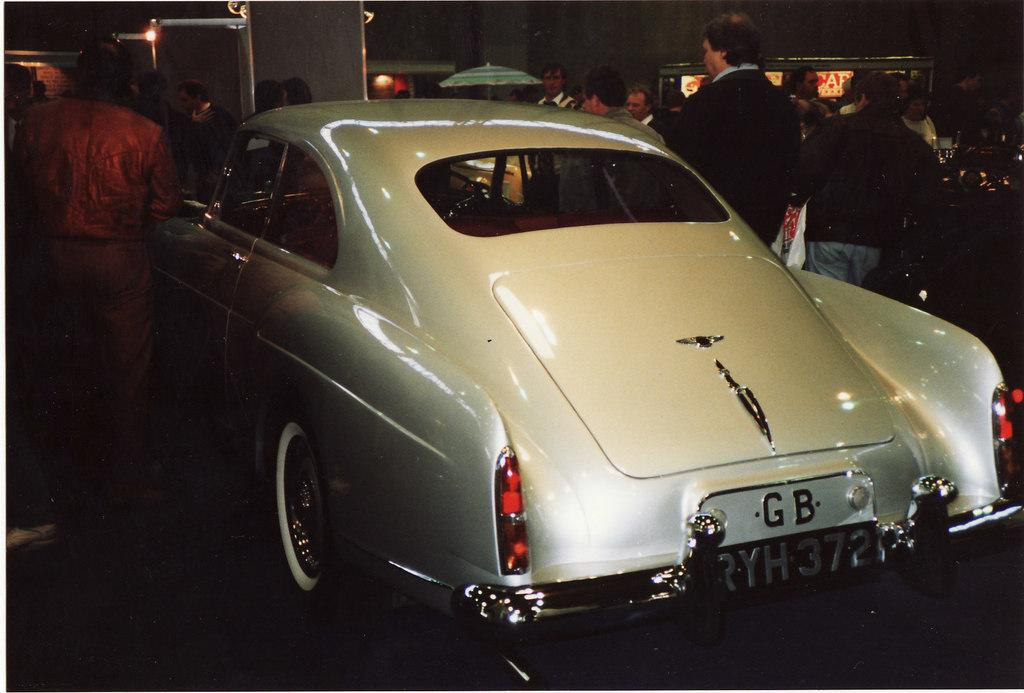What type of vehicle is in the image? There is a white car in the image. What can be seen on the car to identify it? The car has a number plate. What is happening in the background of the image? There are people standing in the background of the image, and there are lights visible. What type of cake is being served to the people in the image? There is no cake present in the image; it features a white car with a number plate and people standing in the background. How many chairs are visible in the image? There are no chairs visible in the image; it features a white car with a number plate and people standing in the background. 